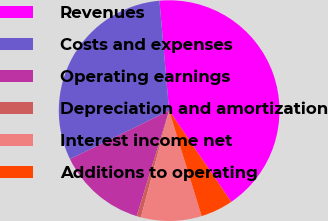Convert chart to OTSL. <chart><loc_0><loc_0><loc_500><loc_500><pie_chart><fcel>Revenues<fcel>Costs and expenses<fcel>Operating earnings<fcel>Depreciation and amortization<fcel>Interest income net<fcel>Additions to operating<nl><fcel>41.89%<fcel>30.85%<fcel>13.01%<fcel>0.63%<fcel>8.88%<fcel>4.75%<nl></chart> 